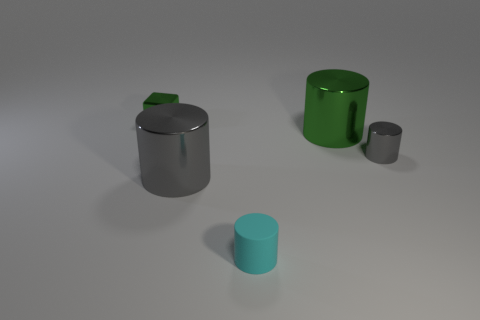Add 2 tiny shiny blocks. How many objects exist? 7 Subtract all cubes. How many objects are left? 4 Subtract 0 red balls. How many objects are left? 5 Subtract all tiny gray shiny objects. Subtract all cyan cylinders. How many objects are left? 3 Add 3 green metallic blocks. How many green metallic blocks are left? 4 Add 1 big brown metal cylinders. How many big brown metal cylinders exist? 1 